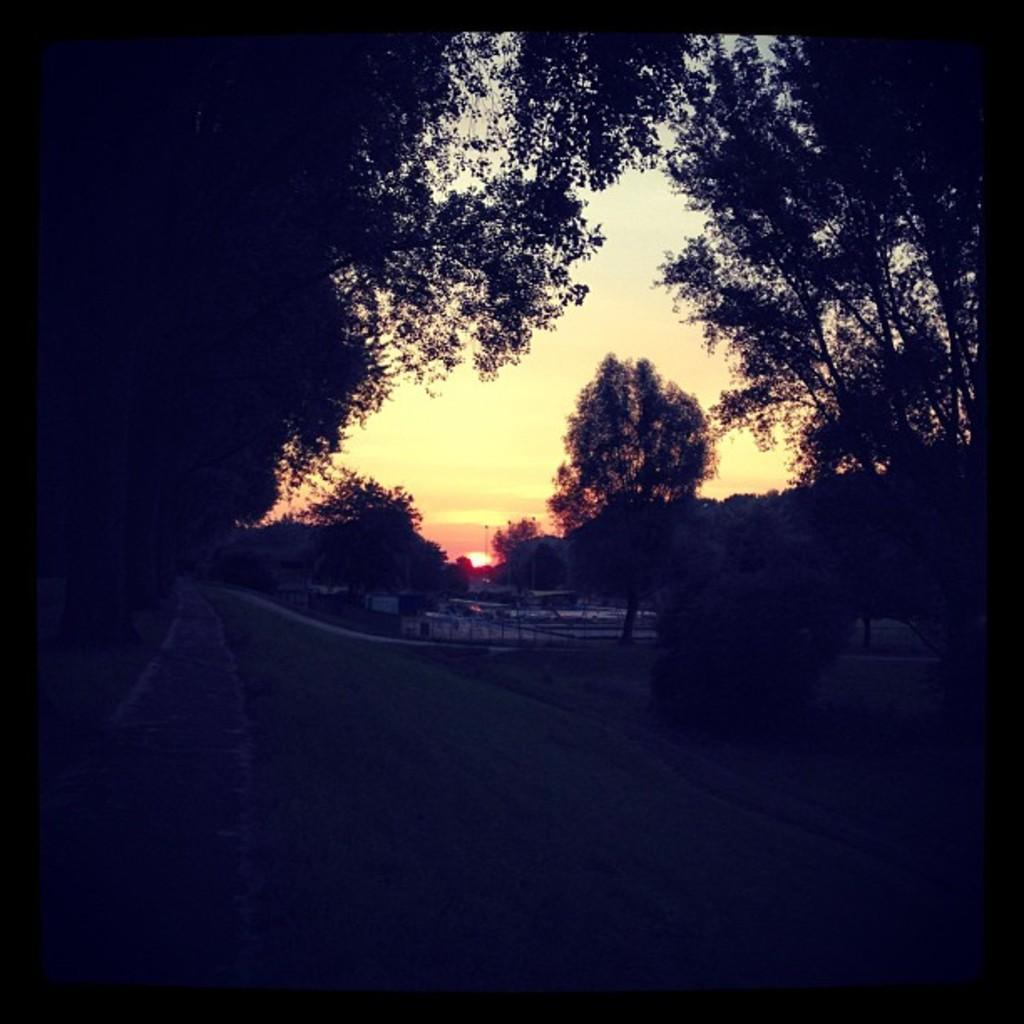What type of natural elements can be seen in the image? There are trees in the image. What type of man-made structures are visible in the background? There are buildings in the background of the image. What celestial body is visible in the image? The sun is visible in the image. What is the color of the sky in the image? The sky appears to be white in color. How many legs does the father have in the image? There is no father present in the image, so it is not possible to determine the number of legs. What type of machine can be seen operating in the image? There is no machine present in the image; it features trees, buildings, the sun, and a white sky. 